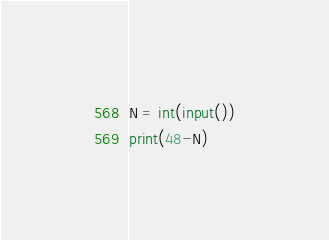<code> <loc_0><loc_0><loc_500><loc_500><_Python_>N = int(input())
print(48-N)</code> 